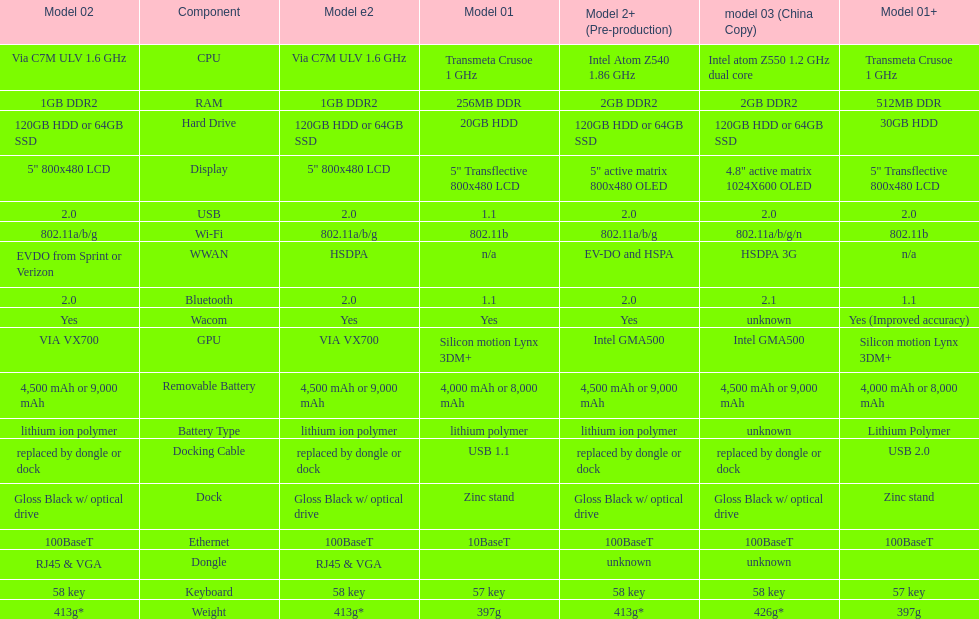What is the component before usb? Display. 